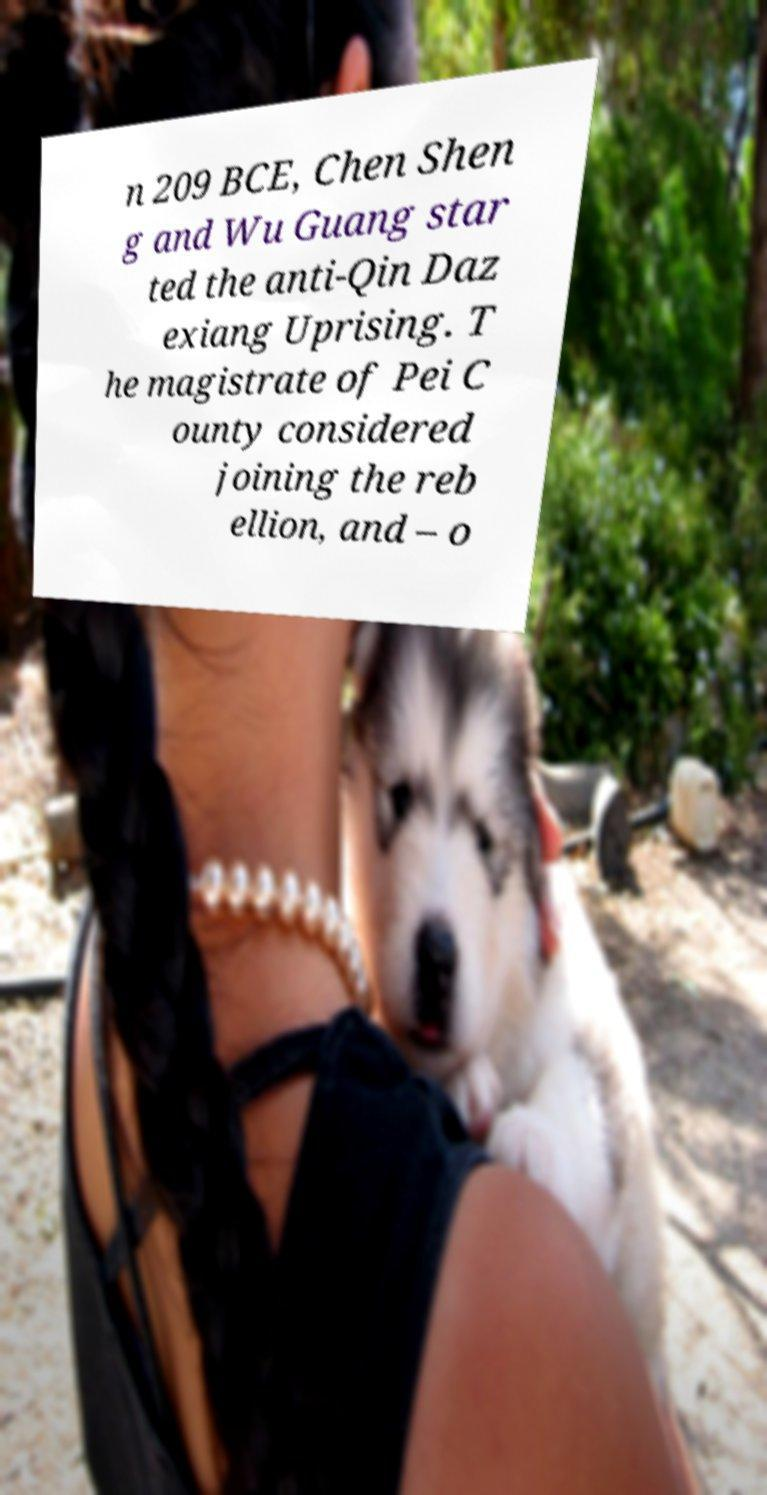Can you read and provide the text displayed in the image?This photo seems to have some interesting text. Can you extract and type it out for me? n 209 BCE, Chen Shen g and Wu Guang star ted the anti-Qin Daz exiang Uprising. T he magistrate of Pei C ounty considered joining the reb ellion, and – o 